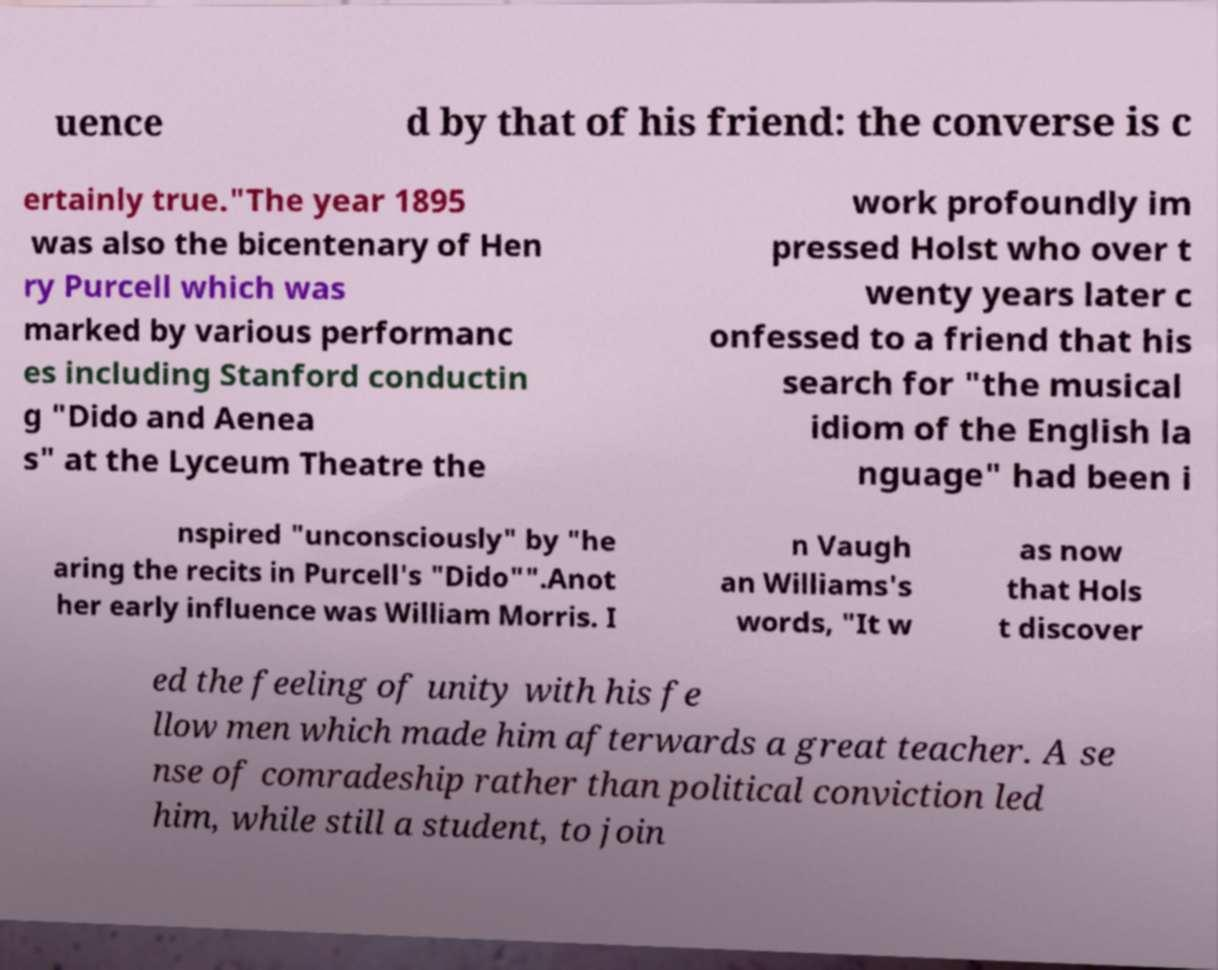I need the written content from this picture converted into text. Can you do that? uence d by that of his friend: the converse is c ertainly true."The year 1895 was also the bicentenary of Hen ry Purcell which was marked by various performanc es including Stanford conductin g "Dido and Aenea s" at the Lyceum Theatre the work profoundly im pressed Holst who over t wenty years later c onfessed to a friend that his search for "the musical idiom of the English la nguage" had been i nspired "unconsciously" by "he aring the recits in Purcell's "Dido"".Anot her early influence was William Morris. I n Vaugh an Williams's words, "It w as now that Hols t discover ed the feeling of unity with his fe llow men which made him afterwards a great teacher. A se nse of comradeship rather than political conviction led him, while still a student, to join 